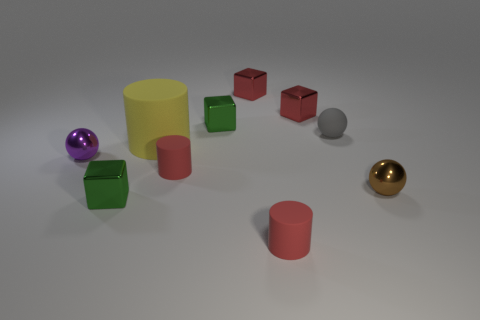What color is the small metal block that is on the left side of the big rubber thing that is on the right side of the metal ball on the left side of the gray object? The small metal block located to the left of the large yellow rubber cylinder, which is itself to the right of the metallic ball on the left side of the gray object, is green in color. It's a rich, vibrant shade of green that stands out among the variously colored objects in the scene. 